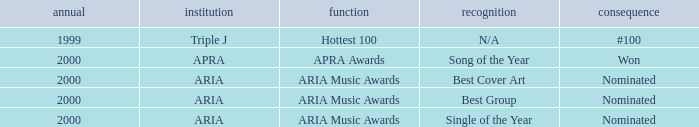What were the results before the year 2000? #100. 